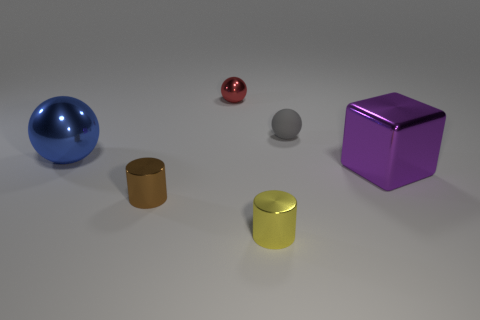Is there anything else that is made of the same material as the tiny gray ball?
Offer a very short reply. No. What number of things are metal balls or objects that are behind the big blue metal object?
Give a very brief answer. 3. What is the shape of the brown thing that is the same size as the gray matte ball?
Your response must be concise. Cylinder. How many large shiny balls have the same color as the matte sphere?
Your answer should be very brief. 0. Do the cylinder to the right of the brown thing and the big blue sphere have the same material?
Your response must be concise. Yes. There is a tiny gray matte object; what shape is it?
Give a very brief answer. Sphere. What number of yellow objects are big blocks or shiny objects?
Offer a terse response. 1. What number of other objects are the same material as the brown object?
Your answer should be very brief. 4. Does the big object that is left of the block have the same shape as the red object?
Your answer should be compact. Yes. Are there any big matte objects?
Your answer should be compact. No. 